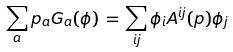<formula> <loc_0><loc_0><loc_500><loc_500>\sum _ { a } p _ { a } G _ { a } ( \phi ) \, = \, \sum _ { i j } \phi _ { i } A ^ { i j } ( p ) \phi _ { j }</formula> 